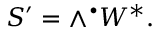Convert formula to latex. <formula><loc_0><loc_0><loc_500><loc_500>S ^ { \prime } = \wedge ^ { \bullet } W ^ { * } .</formula> 